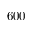Convert formula to latex. <formula><loc_0><loc_0><loc_500><loc_500>6 0 0</formula> 